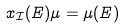Convert formula to latex. <formula><loc_0><loc_0><loc_500><loc_500>x _ { \mathcal { I } } ( E ) \mu = \mu ( E )</formula> 